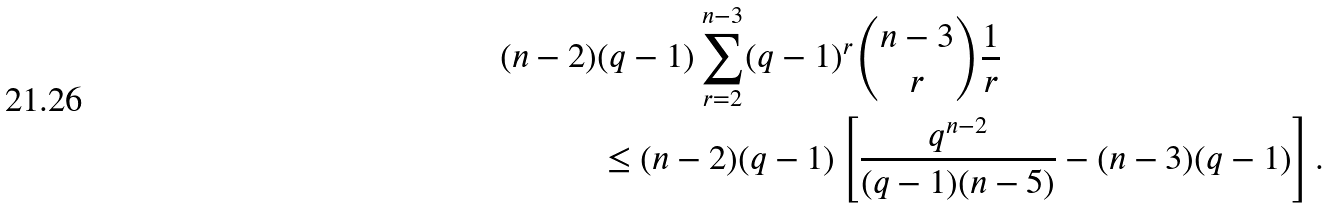Convert formula to latex. <formula><loc_0><loc_0><loc_500><loc_500>( n - 2 ) & ( q - 1 ) \sum _ { r = 2 } ^ { n - 3 } ( q - 1 ) ^ { r } \binom { n - 3 } { r } \frac { 1 } { r } \\ & \leq ( n - 2 ) ( q - 1 ) \left [ \frac { q ^ { n - 2 } } { ( q - 1 ) ( n - 5 ) } - ( n - 3 ) ( q - 1 ) \right ] .</formula> 